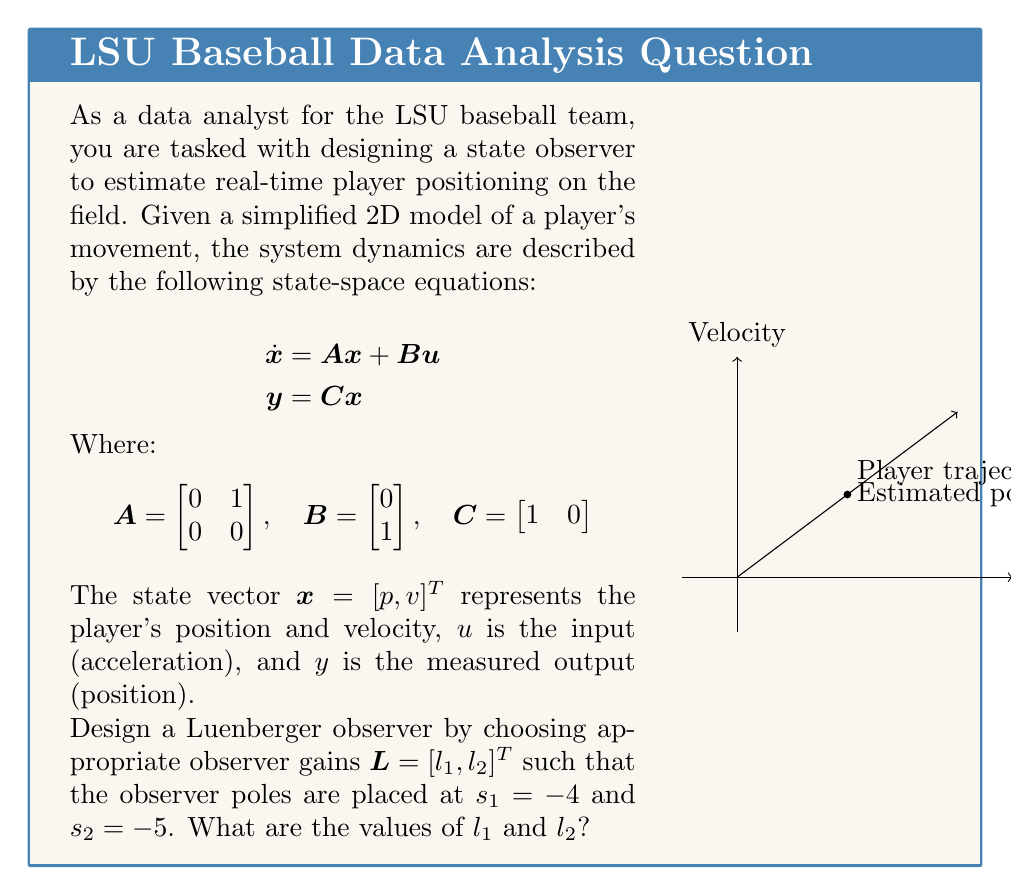Could you help me with this problem? To design a Luenberger observer, we need to follow these steps:

1) The observer dynamics are given by:
   $$\dot{\hat{x}} = A\hat{x} + Bu + L(y - C\hat{x})$$

2) The observer error dynamics are:
   $$\dot{e} = (A - LC)e$$

3) For the given system:
   $$A - LC = \begin{bmatrix} 0 & 1 \\ 0 & 0 \end{bmatrix} - \begin{bmatrix} l_1 \\ l_2 \end{bmatrix} \begin{bmatrix} 1 & 0 \end{bmatrix} = \begin{bmatrix} -l_1 & 1 \\ -l_2 & 0 \end{bmatrix}$$

4) The characteristic equation of the observer is:
   $$\det(sI - (A - LC)) = s^2 + l_1s + l_2 = 0$$

5) We want the observer poles at $s_1 = -4$ and $s_2 = -5$, so the desired characteristic equation is:
   $$(s + 4)(s + 5) = s^2 + 9s + 20 = 0$$

6) Comparing coefficients:
   $$l_1 = 9$$
   $$l_2 = 20$$

Therefore, the observer gain vector $L$ should be:
$$L = \begin{bmatrix} 9 \\ 20 \end{bmatrix}$$
Answer: $l_1 = 9, l_2 = 20$ 